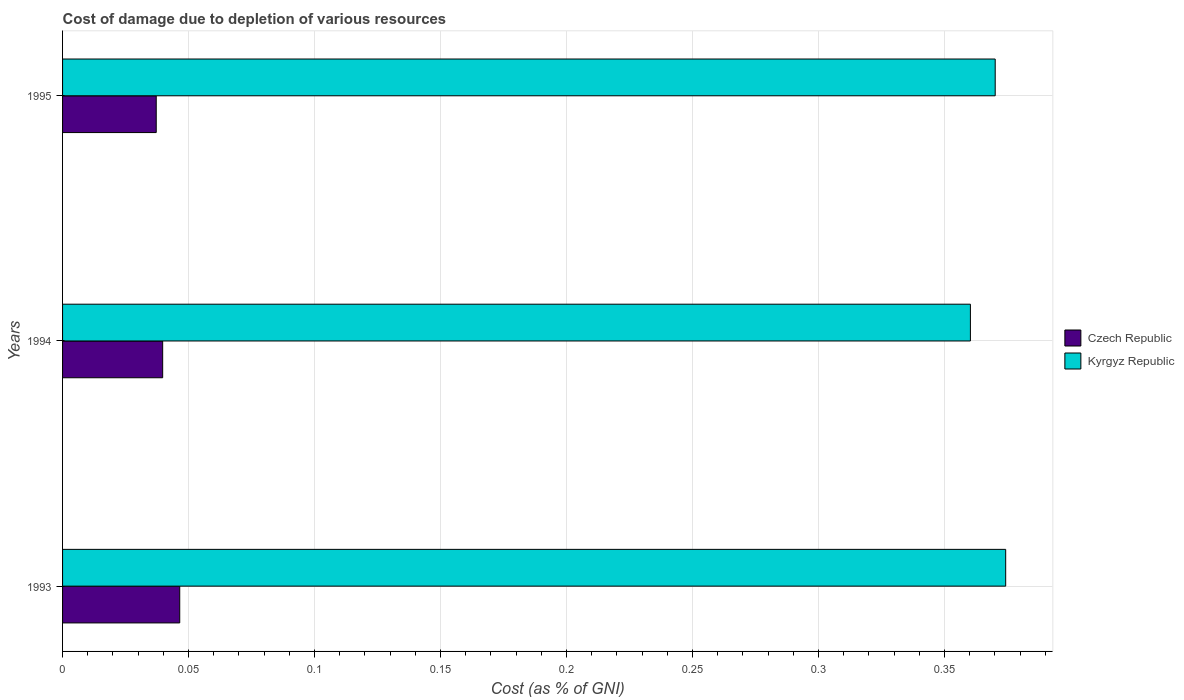How many different coloured bars are there?
Keep it short and to the point. 2. Are the number of bars per tick equal to the number of legend labels?
Your answer should be compact. Yes. Are the number of bars on each tick of the Y-axis equal?
Provide a short and direct response. Yes. How many bars are there on the 3rd tick from the bottom?
Offer a very short reply. 2. In how many cases, is the number of bars for a given year not equal to the number of legend labels?
Give a very brief answer. 0. What is the cost of damage caused due to the depletion of various resources in Czech Republic in 1993?
Make the answer very short. 0.05. Across all years, what is the maximum cost of damage caused due to the depletion of various resources in Kyrgyz Republic?
Provide a succinct answer. 0.37. Across all years, what is the minimum cost of damage caused due to the depletion of various resources in Czech Republic?
Offer a very short reply. 0.04. In which year was the cost of damage caused due to the depletion of various resources in Czech Republic maximum?
Offer a very short reply. 1993. What is the total cost of damage caused due to the depletion of various resources in Kyrgyz Republic in the graph?
Keep it short and to the point. 1.1. What is the difference between the cost of damage caused due to the depletion of various resources in Czech Republic in 1993 and that in 1994?
Give a very brief answer. 0.01. What is the difference between the cost of damage caused due to the depletion of various resources in Kyrgyz Republic in 1994 and the cost of damage caused due to the depletion of various resources in Czech Republic in 1995?
Offer a very short reply. 0.32. What is the average cost of damage caused due to the depletion of various resources in Kyrgyz Republic per year?
Give a very brief answer. 0.37. In the year 1994, what is the difference between the cost of damage caused due to the depletion of various resources in Czech Republic and cost of damage caused due to the depletion of various resources in Kyrgyz Republic?
Give a very brief answer. -0.32. What is the ratio of the cost of damage caused due to the depletion of various resources in Kyrgyz Republic in 1994 to that in 1995?
Provide a short and direct response. 0.97. Is the cost of damage caused due to the depletion of various resources in Czech Republic in 1994 less than that in 1995?
Offer a terse response. No. What is the difference between the highest and the second highest cost of damage caused due to the depletion of various resources in Czech Republic?
Keep it short and to the point. 0.01. What is the difference between the highest and the lowest cost of damage caused due to the depletion of various resources in Kyrgyz Republic?
Your answer should be very brief. 0.01. What does the 2nd bar from the top in 1995 represents?
Provide a short and direct response. Czech Republic. What does the 2nd bar from the bottom in 1994 represents?
Keep it short and to the point. Kyrgyz Republic. How many bars are there?
Provide a short and direct response. 6. How many years are there in the graph?
Your answer should be very brief. 3. Are the values on the major ticks of X-axis written in scientific E-notation?
Keep it short and to the point. No. Does the graph contain any zero values?
Provide a short and direct response. No. Does the graph contain grids?
Keep it short and to the point. Yes. Where does the legend appear in the graph?
Make the answer very short. Center right. How are the legend labels stacked?
Keep it short and to the point. Vertical. What is the title of the graph?
Provide a short and direct response. Cost of damage due to depletion of various resources. What is the label or title of the X-axis?
Give a very brief answer. Cost (as % of GNI). What is the label or title of the Y-axis?
Provide a short and direct response. Years. What is the Cost (as % of GNI) in Czech Republic in 1993?
Your answer should be compact. 0.05. What is the Cost (as % of GNI) of Kyrgyz Republic in 1993?
Provide a short and direct response. 0.37. What is the Cost (as % of GNI) in Czech Republic in 1994?
Ensure brevity in your answer.  0.04. What is the Cost (as % of GNI) of Kyrgyz Republic in 1994?
Offer a very short reply. 0.36. What is the Cost (as % of GNI) of Czech Republic in 1995?
Offer a terse response. 0.04. What is the Cost (as % of GNI) of Kyrgyz Republic in 1995?
Your answer should be very brief. 0.37. Across all years, what is the maximum Cost (as % of GNI) in Czech Republic?
Offer a very short reply. 0.05. Across all years, what is the maximum Cost (as % of GNI) in Kyrgyz Republic?
Keep it short and to the point. 0.37. Across all years, what is the minimum Cost (as % of GNI) in Czech Republic?
Make the answer very short. 0.04. Across all years, what is the minimum Cost (as % of GNI) of Kyrgyz Republic?
Your answer should be compact. 0.36. What is the total Cost (as % of GNI) of Czech Republic in the graph?
Keep it short and to the point. 0.12. What is the total Cost (as % of GNI) of Kyrgyz Republic in the graph?
Give a very brief answer. 1.1. What is the difference between the Cost (as % of GNI) of Czech Republic in 1993 and that in 1994?
Offer a very short reply. 0.01. What is the difference between the Cost (as % of GNI) in Kyrgyz Republic in 1993 and that in 1994?
Keep it short and to the point. 0.01. What is the difference between the Cost (as % of GNI) of Czech Republic in 1993 and that in 1995?
Provide a short and direct response. 0.01. What is the difference between the Cost (as % of GNI) of Kyrgyz Republic in 1993 and that in 1995?
Give a very brief answer. 0. What is the difference between the Cost (as % of GNI) of Czech Republic in 1994 and that in 1995?
Give a very brief answer. 0. What is the difference between the Cost (as % of GNI) in Kyrgyz Republic in 1994 and that in 1995?
Provide a succinct answer. -0.01. What is the difference between the Cost (as % of GNI) in Czech Republic in 1993 and the Cost (as % of GNI) in Kyrgyz Republic in 1994?
Provide a succinct answer. -0.31. What is the difference between the Cost (as % of GNI) of Czech Republic in 1993 and the Cost (as % of GNI) of Kyrgyz Republic in 1995?
Provide a succinct answer. -0.32. What is the difference between the Cost (as % of GNI) of Czech Republic in 1994 and the Cost (as % of GNI) of Kyrgyz Republic in 1995?
Provide a succinct answer. -0.33. What is the average Cost (as % of GNI) in Czech Republic per year?
Offer a very short reply. 0.04. What is the average Cost (as % of GNI) of Kyrgyz Republic per year?
Give a very brief answer. 0.37. In the year 1993, what is the difference between the Cost (as % of GNI) in Czech Republic and Cost (as % of GNI) in Kyrgyz Republic?
Your answer should be compact. -0.33. In the year 1994, what is the difference between the Cost (as % of GNI) in Czech Republic and Cost (as % of GNI) in Kyrgyz Republic?
Your answer should be very brief. -0.32. In the year 1995, what is the difference between the Cost (as % of GNI) in Czech Republic and Cost (as % of GNI) in Kyrgyz Republic?
Ensure brevity in your answer.  -0.33. What is the ratio of the Cost (as % of GNI) of Czech Republic in 1993 to that in 1994?
Offer a very short reply. 1.17. What is the ratio of the Cost (as % of GNI) in Kyrgyz Republic in 1993 to that in 1994?
Give a very brief answer. 1.04. What is the ratio of the Cost (as % of GNI) of Czech Republic in 1993 to that in 1995?
Give a very brief answer. 1.25. What is the ratio of the Cost (as % of GNI) of Kyrgyz Republic in 1993 to that in 1995?
Ensure brevity in your answer.  1.01. What is the ratio of the Cost (as % of GNI) in Czech Republic in 1994 to that in 1995?
Your answer should be very brief. 1.07. What is the ratio of the Cost (as % of GNI) of Kyrgyz Republic in 1994 to that in 1995?
Offer a very short reply. 0.97. What is the difference between the highest and the second highest Cost (as % of GNI) in Czech Republic?
Provide a short and direct response. 0.01. What is the difference between the highest and the second highest Cost (as % of GNI) in Kyrgyz Republic?
Give a very brief answer. 0. What is the difference between the highest and the lowest Cost (as % of GNI) of Czech Republic?
Give a very brief answer. 0.01. What is the difference between the highest and the lowest Cost (as % of GNI) in Kyrgyz Republic?
Provide a short and direct response. 0.01. 